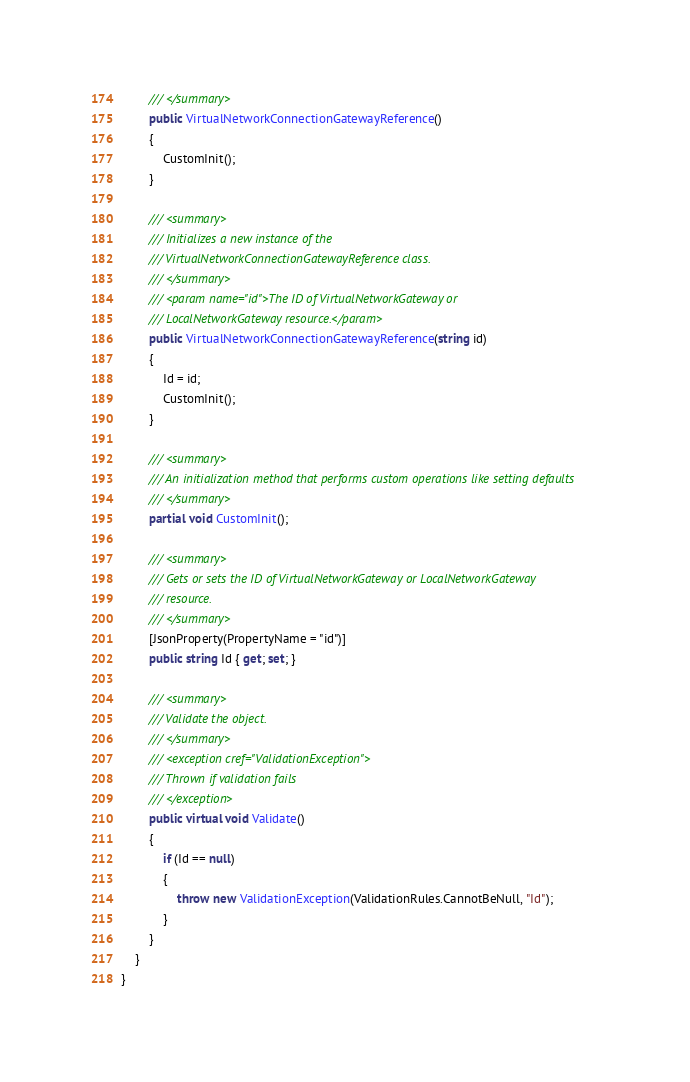<code> <loc_0><loc_0><loc_500><loc_500><_C#_>        /// </summary>
        public VirtualNetworkConnectionGatewayReference()
        {
            CustomInit();
        }

        /// <summary>
        /// Initializes a new instance of the
        /// VirtualNetworkConnectionGatewayReference class.
        /// </summary>
        /// <param name="id">The ID of VirtualNetworkGateway or
        /// LocalNetworkGateway resource.</param>
        public VirtualNetworkConnectionGatewayReference(string id)
        {
            Id = id;
            CustomInit();
        }

        /// <summary>
        /// An initialization method that performs custom operations like setting defaults
        /// </summary>
        partial void CustomInit();

        /// <summary>
        /// Gets or sets the ID of VirtualNetworkGateway or LocalNetworkGateway
        /// resource.
        /// </summary>
        [JsonProperty(PropertyName = "id")]
        public string Id { get; set; }

        /// <summary>
        /// Validate the object.
        /// </summary>
        /// <exception cref="ValidationException">
        /// Thrown if validation fails
        /// </exception>
        public virtual void Validate()
        {
            if (Id == null)
            {
                throw new ValidationException(ValidationRules.CannotBeNull, "Id");
            }
        }
    }
}
</code> 